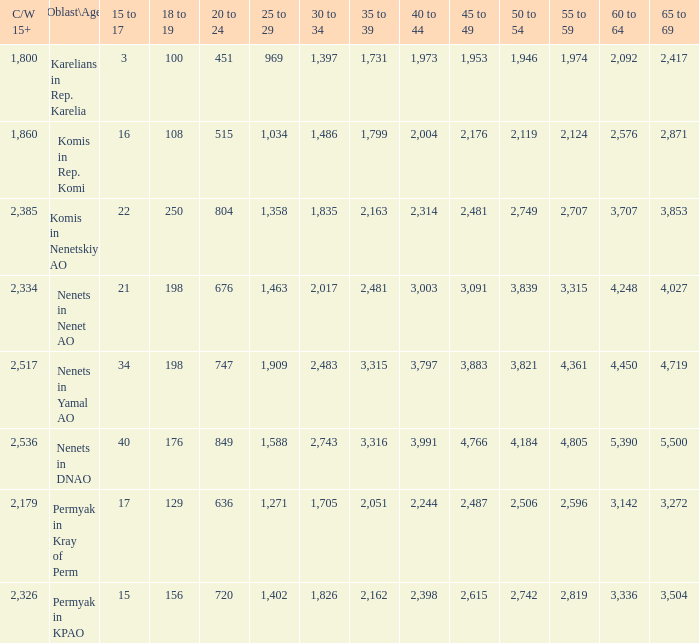What is the sum of 30 to 34 when the 40 to 44 range exceeds 3,003, and the 50 to 54 range surpasses 4,184? None. 